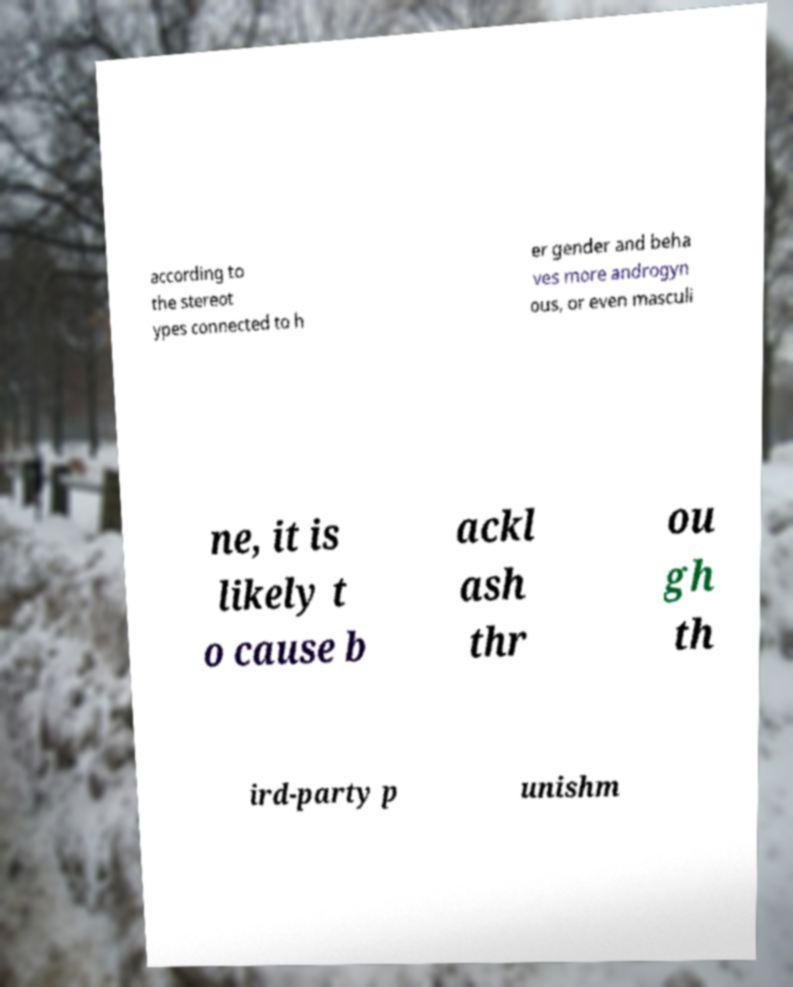Please identify and transcribe the text found in this image. according to the stereot ypes connected to h er gender and beha ves more androgyn ous, or even masculi ne, it is likely t o cause b ackl ash thr ou gh th ird-party p unishm 